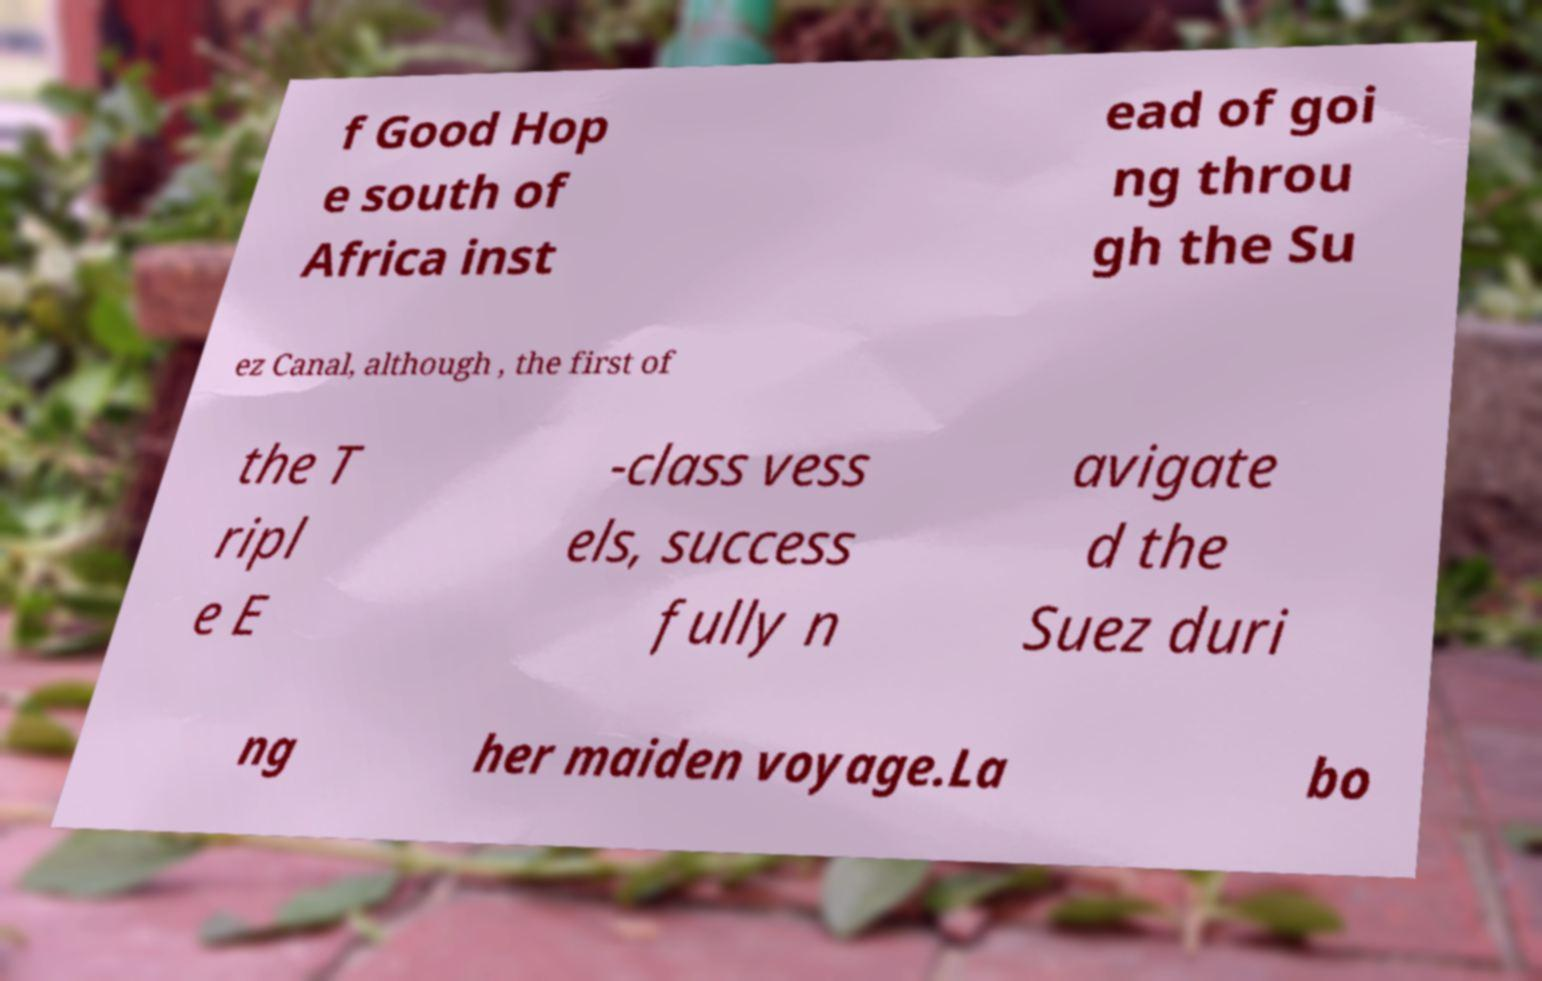Please identify and transcribe the text found in this image. f Good Hop e south of Africa inst ead of goi ng throu gh the Su ez Canal, although , the first of the T ripl e E -class vess els, success fully n avigate d the Suez duri ng her maiden voyage.La bo 